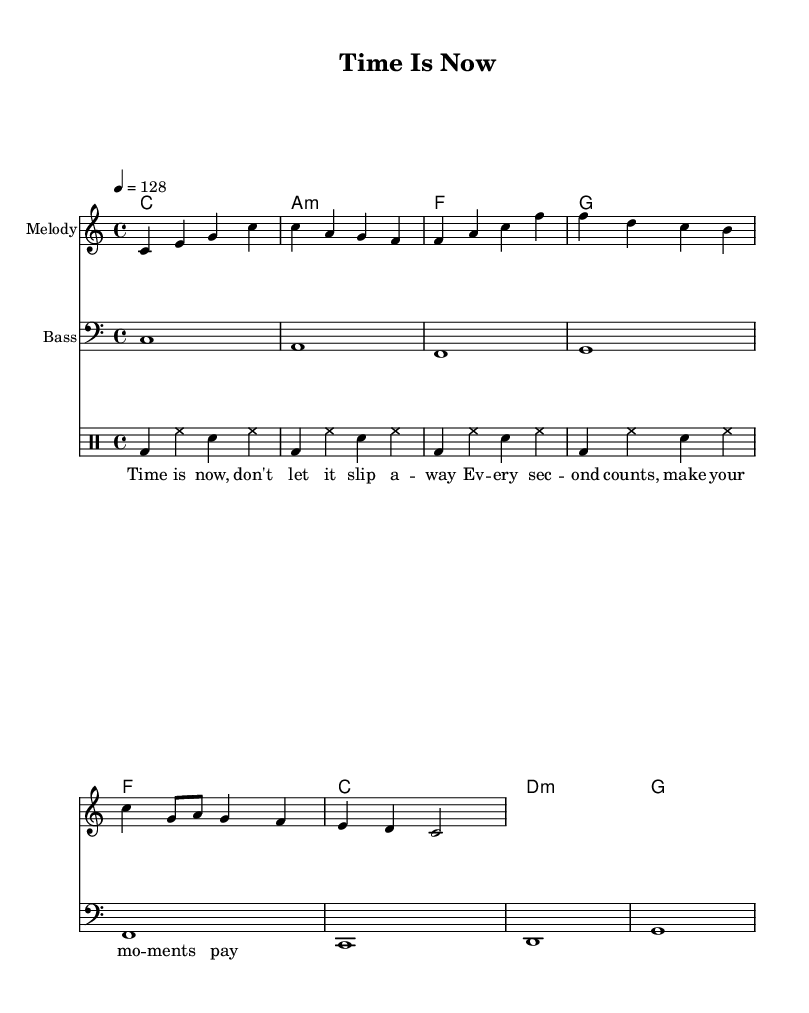What is the key signature of this music? The key signature is indicated at the beginning of the staff. In this case, it is C major, which has no sharps or flats.
Answer: C major What is the time signature of this piece? The time signature is found next to the key signature at the beginning of the music. Here, it is 4/4, which means there are four beats in a measure.
Answer: 4/4 What is the tempo of the piece? The tempo is indicated at the beginning of the score with a marking that refers to beats per minute. In this case, it says 4 = 128, meaning there are 128 beats per minute.
Answer: 128 How many measures are in the melody? Counting the bar lines in the melody section shows that there are a total of eight measures in the melody.
Answer: 8 What is the chord progression in the piece? By examining the chords shown in the ChordNames section, the progression is C, A minor, F, G, F, C, D minor, G. This can be deduced from the sequence of chords listed.
Answer: C, A minor, F, G, F, C, D minor, G Which instrument plays the bass? The bass is indicated to be played by the staff labeled as "Bass" at the beginning of that section.
Answer: Bass What is the central theme of the lyrics? The lyrics reflect a motivational theme, emphasizing the importance of time management and making the most out of each moment. This can be derived from the words used in the lyric section.
Answer: Time management 